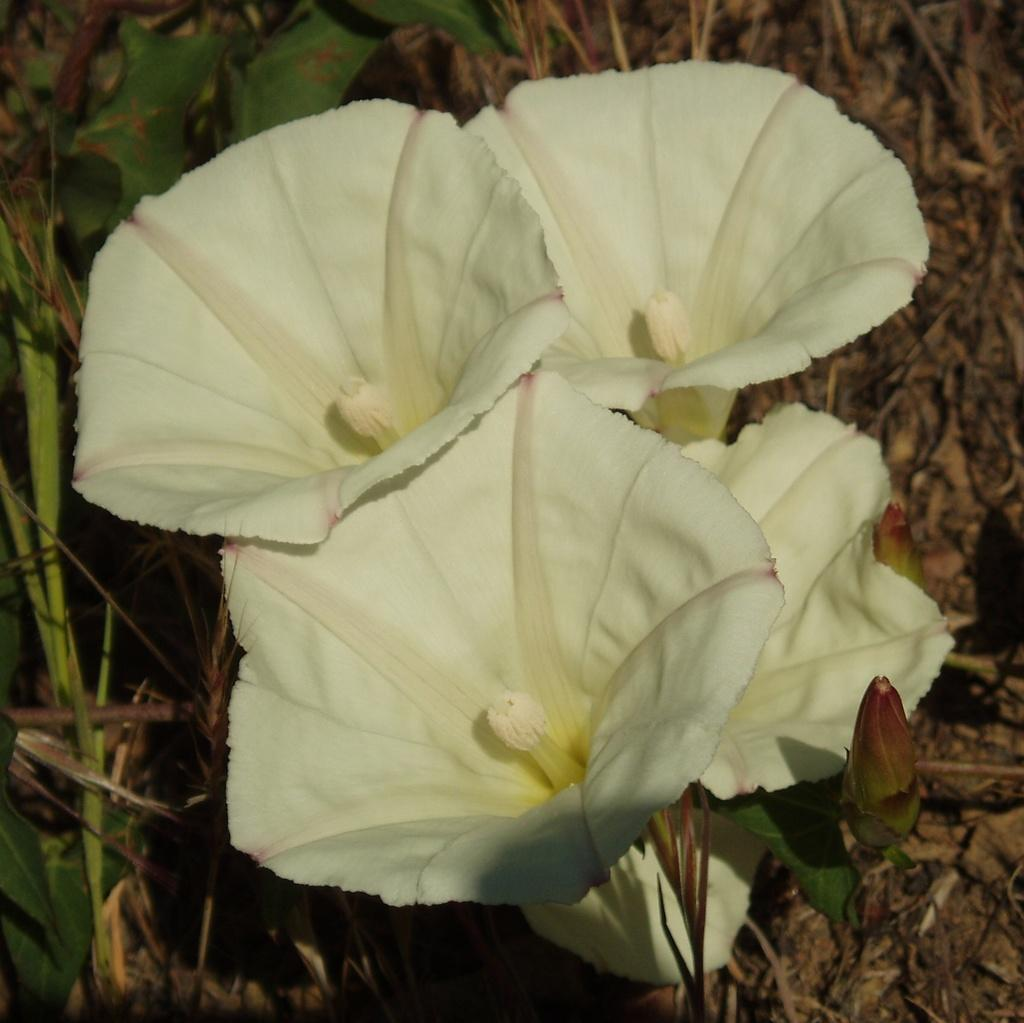What type of flora is present in the image? There are flowers in the image. What color are the flowers? The flowers are white. Are there any other types of plants visible in the image? Yes, there are plants visible in the image. What type of haircut can be seen on the flowers in the image? There is no hair or haircut present on the flowers in the image, as flowers do not have hair. 